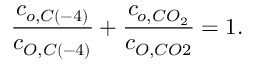Convert formula to latex. <formula><loc_0><loc_0><loc_500><loc_500>\frac { c _ { o , C \left ( - 4 \right ) } } { c _ { O , C \left ( - 4 \right ) } } + \frac { c _ { o , C O _ { 2 } } } { c _ { O , C O 2 } } = 1 .</formula> 